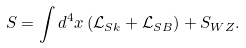Convert formula to latex. <formula><loc_0><loc_0><loc_500><loc_500>S = \int d ^ { 4 } x \left ( \mathcal { L } _ { S k } + \mathcal { L } _ { S B } \right ) + S _ { W Z } .</formula> 